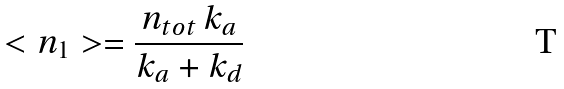Convert formula to latex. <formula><loc_0><loc_0><loc_500><loc_500>< n _ { 1 } > = \frac { n _ { t o t } \, k _ { a } } { k _ { a } + k _ { d } }</formula> 